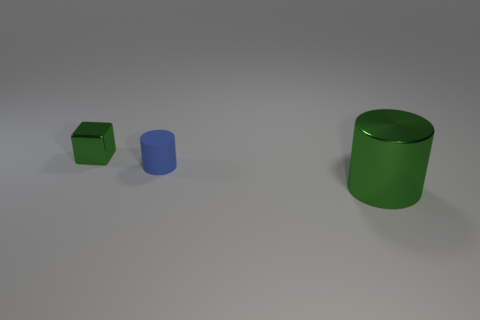There is another green thing that is the same shape as the tiny matte thing; what is it made of?
Offer a terse response. Metal. How many rubber things are small purple spheres or small cylinders?
Keep it short and to the point. 1. What shape is the green thing that is the same material as the large green cylinder?
Offer a very short reply. Cube. How many matte things have the same shape as the big metallic object?
Make the answer very short. 1. There is a green thing that is in front of the tiny matte object; is it the same shape as the small object to the right of the tiny metal cube?
Give a very brief answer. Yes. How many things are tiny matte objects or green things that are on the right side of the blue matte cylinder?
Give a very brief answer. 2. What is the shape of the metal object that is the same color as the tiny metallic block?
Your answer should be compact. Cylinder. How many matte things are the same size as the matte cylinder?
Offer a very short reply. 0. What number of green objects are either metallic things or tiny objects?
Give a very brief answer. 2. There is a small object that is right of the green object behind the metal cylinder; what shape is it?
Your answer should be very brief. Cylinder. 